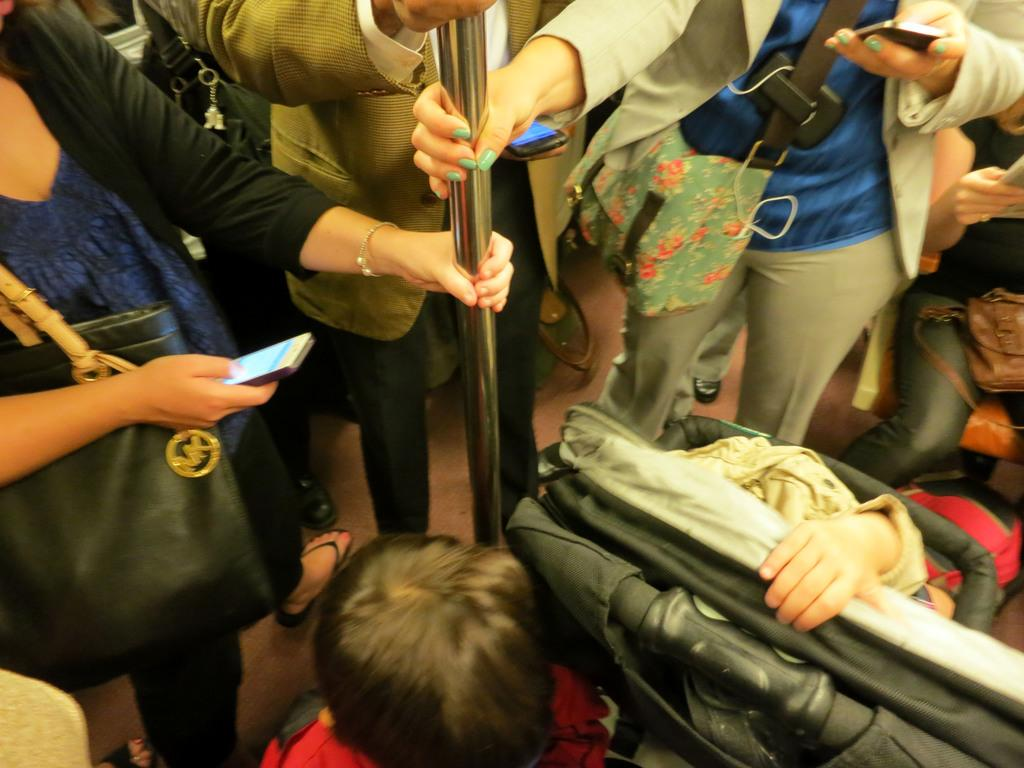How many people are standing at the top of the image? There are three persons standing at the top of the image. What are the standing persons holding? The standing persons are holding a rod. What are the people at the bottom of the image doing? The people at the bottom of the image are sitting. What is the texture of the pencil in the image? There is no pencil present in the image. 